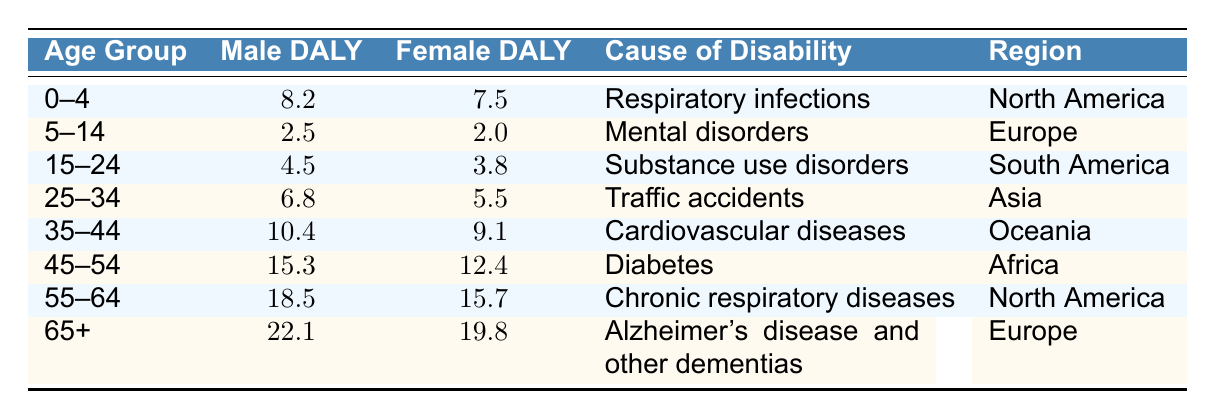What is the male DALY for the age group 45-54? According to the table, the male DALY for the age group 45-54 is listed directly in the row corresponding to that age group. The value is 15.3.
Answer: 15.3 In which region does the age group 55-64 have the highest female DALY compared to other age groups? Looking at the table, the female DALY for the age group 55-64 is 15.7, which is higher than any other age group listed. Thus, it is the highest for 55-64 in North America.
Answer: North America What is the difference between male and female DALY for the age group 25-34? The male DALY for the age group 25-34 is 6.8, and the female DALY is 5.5. To find the difference, subtract the female DALY from the male DALY: 6.8 - 5.5 = 1.3.
Answer: 1.3 Which cause of disability associated with the age group 65+ has the highest male DALY? The table shows that for the age group 65+, the cause of disability is Alzheimer's disease and other dementias, which has a male DALY of 22.1. Since this is the only entry for that age group, it is also the highest.
Answer: Alzheimer's disease and other dementias Is it true that females in the age group 0-4 have a higher DALY than those in 5-14? The table indicates that the female DALY for the age group 0-4 is 7.5, while for 5-14 it is 2.0. Since 7.5 is greater than 2.0, the statement is true.
Answer: Yes What is the average male DALY across all age groups listed in the table? To calculate the average male DALY, first sum all male DALY values: 8.2 + 2.5 + 4.5 + 6.8 + 10.4 + 15.3 + 18.5 + 22.1 = 88.0. There are 8 age groups, so the average is 88.0 / 8 = 11.0.
Answer: 11.0 Do males have a higher DALY than females in all the age groups? By examining each row in the table, males have higher DALY values in the age groups 0-4, 15-24, 25-34, 35-44, 45-54, 55-64, and 65+. Therefore, the statement is true; however, we need to analyze each group to be certain.
Answer: No What is the cause of disability with the lowest DALY for females? By reviewing the table, the lowest female DALY value is in the age group 5-14, associated with the cause of mental disorders where the female DALY is 2.0.
Answer: Mental disorders 